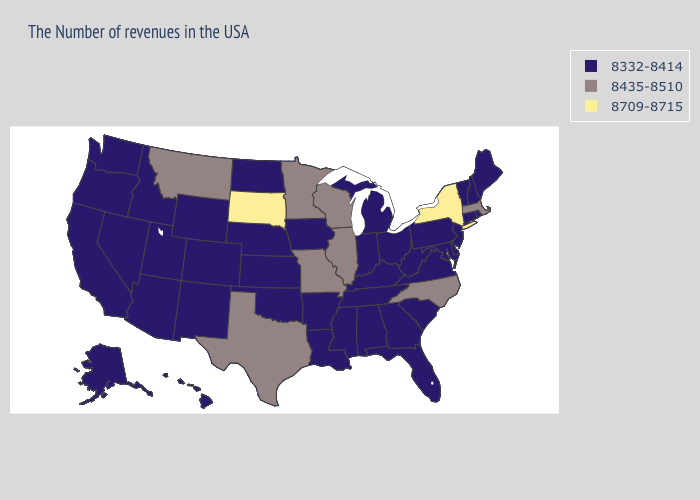Name the states that have a value in the range 8332-8414?
Concise answer only. Maine, Rhode Island, New Hampshire, Vermont, Connecticut, New Jersey, Delaware, Maryland, Pennsylvania, Virginia, South Carolina, West Virginia, Ohio, Florida, Georgia, Michigan, Kentucky, Indiana, Alabama, Tennessee, Mississippi, Louisiana, Arkansas, Iowa, Kansas, Nebraska, Oklahoma, North Dakota, Wyoming, Colorado, New Mexico, Utah, Arizona, Idaho, Nevada, California, Washington, Oregon, Alaska, Hawaii. Does New Mexico have the same value as Wisconsin?
Keep it brief. No. Does the map have missing data?
Quick response, please. No. What is the highest value in the USA?
Give a very brief answer. 8709-8715. Name the states that have a value in the range 8435-8510?
Answer briefly. Massachusetts, North Carolina, Wisconsin, Illinois, Missouri, Minnesota, Texas, Montana. Among the states that border Massachusetts , which have the lowest value?
Keep it brief. Rhode Island, New Hampshire, Vermont, Connecticut. What is the lowest value in states that border Pennsylvania?
Keep it brief. 8332-8414. What is the lowest value in the MidWest?
Write a very short answer. 8332-8414. Name the states that have a value in the range 8435-8510?
Short answer required. Massachusetts, North Carolina, Wisconsin, Illinois, Missouri, Minnesota, Texas, Montana. Name the states that have a value in the range 8435-8510?
Answer briefly. Massachusetts, North Carolina, Wisconsin, Illinois, Missouri, Minnesota, Texas, Montana. Name the states that have a value in the range 8435-8510?
Give a very brief answer. Massachusetts, North Carolina, Wisconsin, Illinois, Missouri, Minnesota, Texas, Montana. Which states have the highest value in the USA?
Short answer required. New York, South Dakota. Name the states that have a value in the range 8332-8414?
Give a very brief answer. Maine, Rhode Island, New Hampshire, Vermont, Connecticut, New Jersey, Delaware, Maryland, Pennsylvania, Virginia, South Carolina, West Virginia, Ohio, Florida, Georgia, Michigan, Kentucky, Indiana, Alabama, Tennessee, Mississippi, Louisiana, Arkansas, Iowa, Kansas, Nebraska, Oklahoma, North Dakota, Wyoming, Colorado, New Mexico, Utah, Arizona, Idaho, Nevada, California, Washington, Oregon, Alaska, Hawaii. 